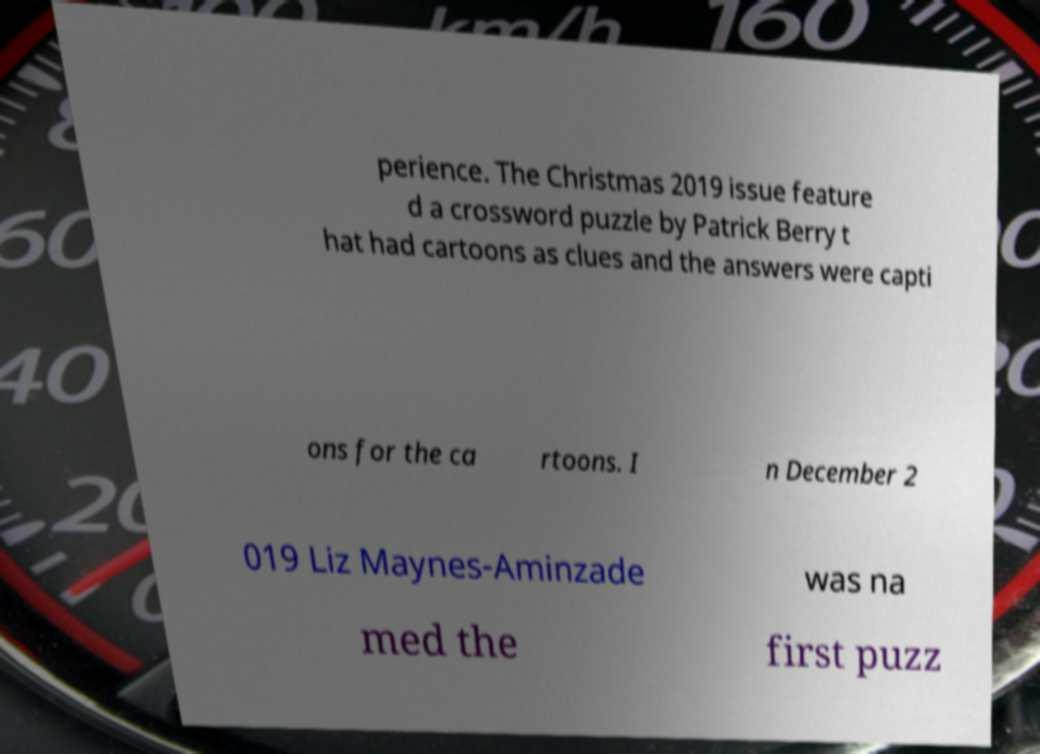Please read and relay the text visible in this image. What does it say? perience. The Christmas 2019 issue feature d a crossword puzzle by Patrick Berry t hat had cartoons as clues and the answers were capti ons for the ca rtoons. I n December 2 019 Liz Maynes-Aminzade was na med the first puzz 